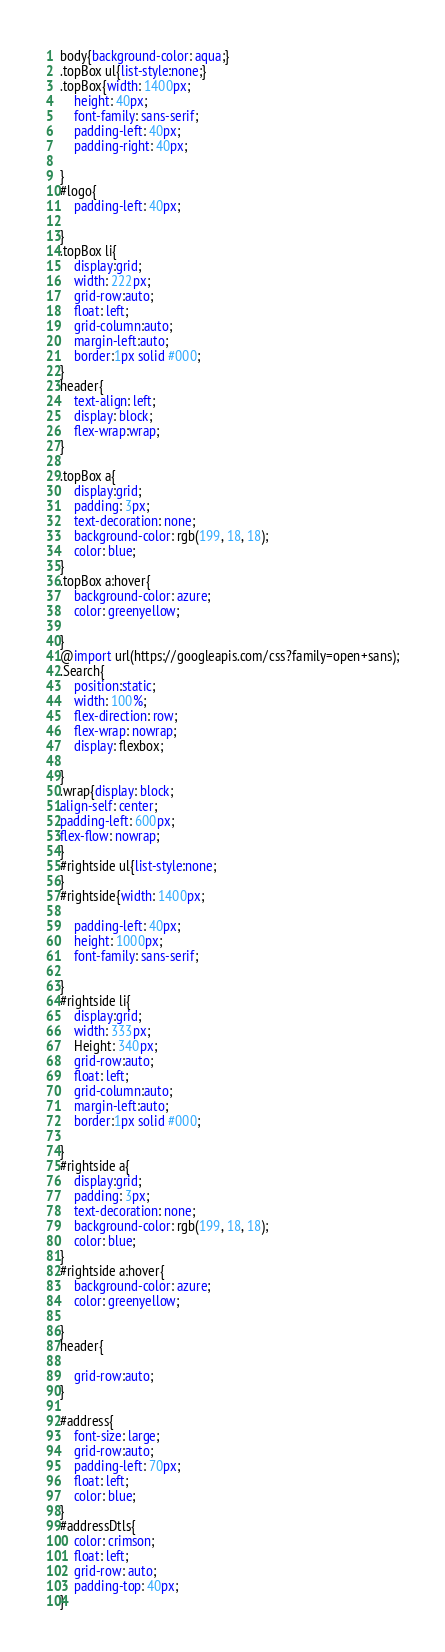<code> <loc_0><loc_0><loc_500><loc_500><_CSS_>body{background-color: aqua;}
.topBox ul{list-style:none;}
.topBox{width: 1400px;
    height: 40px;
    font-family: sans-serif;
    padding-left: 40px;
    padding-right: 40px;
   
}
#logo{
    padding-left: 40px;
   
}
.topBox li{
    display:grid;
	width: 222px;
	grid-row:auto;
    float: left;
    grid-column:auto;
	margin-left:auto;
	border:1px solid #000;
}
header{
    text-align: left;
    display: block;
    flex-wrap:wrap;
}

.topBox a{
    display:grid;
    padding: 3px;
    text-decoration: none;
    background-color: rgb(199, 18, 18);
    color: blue;
}
.topBox a:hover{
    background-color: azure;
    color: greenyellow;
    
}
@import url(https://googleapis.com/css?family=open+sans);
.Search{
    position:static;
    width: 100%;
    flex-direction: row;
    flex-wrap: nowrap;
    display: flexbox;

}
.wrap{display: block;
align-self: center;
padding-left: 600px;
flex-flow: nowrap;
}
#rightside ul{list-style:none;
}
#rightside{width: 1400px;
 
    padding-left: 40px;
    height: 1000px;
    font-family: sans-serif;

}
#rightside li{
    display:grid;
	width: 333px;
    Height: 340px;
	grid-row:auto;
    float: left;
    grid-column:auto;
	margin-left:auto;
	border:1px solid #000;   

}
#rightside a{
    display:grid;
    padding: 3px;
    text-decoration: none;
    background-color: rgb(199, 18, 18);
    color: blue;
}
#rightside a:hover{
    background-color: azure;
    color: greenyellow;
    
}
header{

    grid-row:auto;
}

#address{
    font-size: large;
    grid-row:auto;
    padding-left: 70px;
    float: left;
    color: blue;
}
#addressDtls{
    color: crimson;
    float: left;
    grid-row: auto;
    padding-top: 40px;
}</code> 